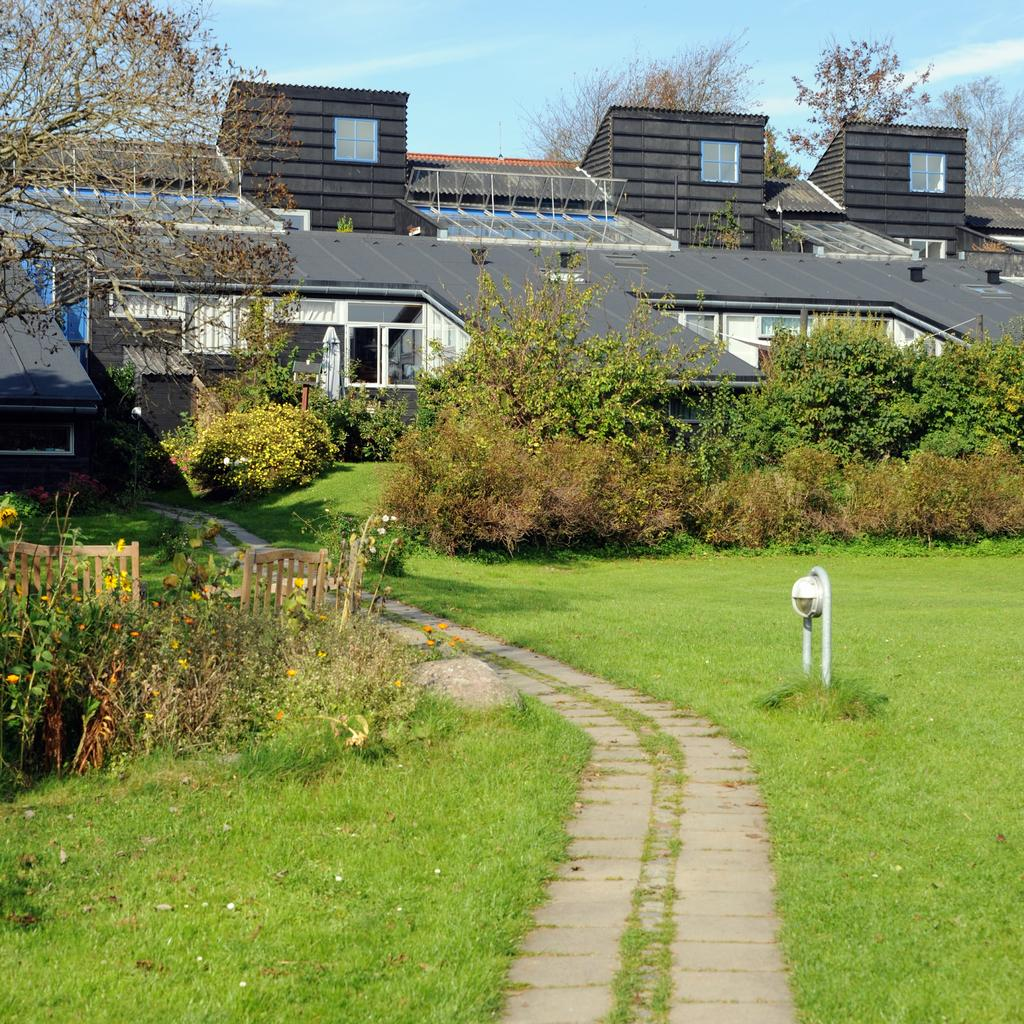What type of furniture is present in the image? There are chairs in the image. What other objects can be seen in the image? There are plants in the image. What can be seen in the background of the image? There are buildings, plants, and trees in the background of the image. Is there any indication of a path or walkway in the image? Yes, there is a path in the image. How does the temper of the plants affect the image? The temper of the plants is not mentioned in the image, and therefore it cannot be determined how it might affect the image. Is there any indication of an attack happening in the image? There is no indication of an attack in the image; it features chairs, plants, buildings, and a path. 